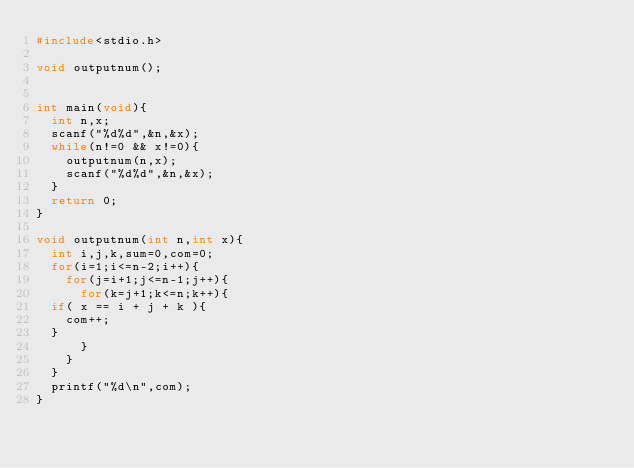Convert code to text. <code><loc_0><loc_0><loc_500><loc_500><_C_>#include<stdio.h>

void outputnum();


int main(void){
  int n,x;
  scanf("%d%d",&n,&x);
  while(n!=0 && x!=0){
    outputnum(n,x);
    scanf("%d%d",&n,&x);
  }
  return 0;
}

void outputnum(int n,int x){
  int i,j,k,sum=0,com=0;
  for(i=1;i<=n-2;i++){
    for(j=i+1;j<=n-1;j++){
      for(k=j+1;k<=n;k++){
	if( x == i + j + k ){
	  com++;
	}
      }
    }
  }
  printf("%d\n",com);
}</code> 